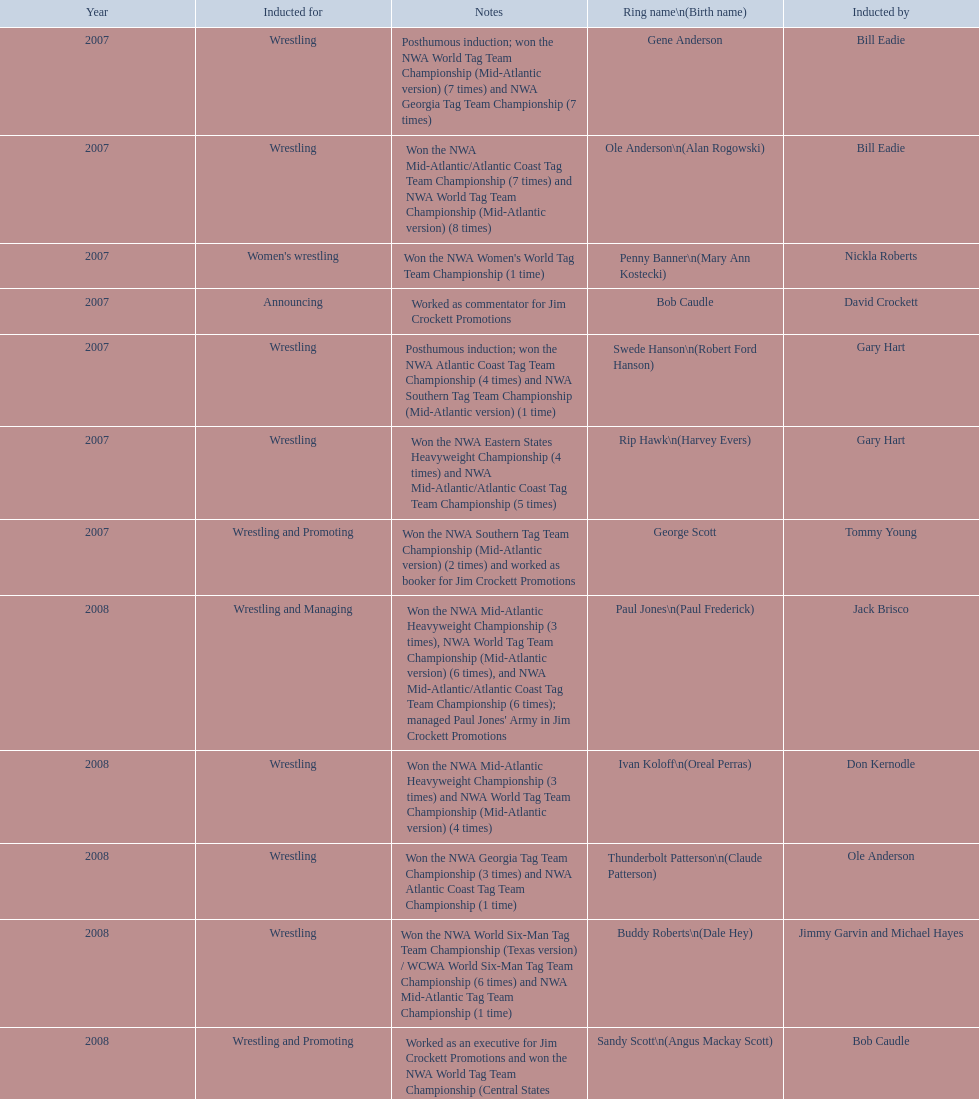Can you give me this table as a dict? {'header': ['Year', 'Inducted for', 'Notes', 'Ring name\\n(Birth name)', 'Inducted by'], 'rows': [['2007', 'Wrestling', 'Posthumous induction; won the NWA World Tag Team Championship (Mid-Atlantic version) (7 times) and NWA Georgia Tag Team Championship (7 times)', 'Gene Anderson', 'Bill Eadie'], ['2007', 'Wrestling', 'Won the NWA Mid-Atlantic/Atlantic Coast Tag Team Championship (7 times) and NWA World Tag Team Championship (Mid-Atlantic version) (8 times)', 'Ole Anderson\\n(Alan Rogowski)', 'Bill Eadie'], ['2007', "Women's wrestling", "Won the NWA Women's World Tag Team Championship (1 time)", 'Penny Banner\\n(Mary Ann Kostecki)', 'Nickla Roberts'], ['2007', 'Announcing', 'Worked as commentator for Jim Crockett Promotions', 'Bob Caudle', 'David Crockett'], ['2007', 'Wrestling', 'Posthumous induction; won the NWA Atlantic Coast Tag Team Championship (4 times) and NWA Southern Tag Team Championship (Mid-Atlantic version) (1 time)', 'Swede Hanson\\n(Robert Ford Hanson)', 'Gary Hart'], ['2007', 'Wrestling', 'Won the NWA Eastern States Heavyweight Championship (4 times) and NWA Mid-Atlantic/Atlantic Coast Tag Team Championship (5 times)', 'Rip Hawk\\n(Harvey Evers)', 'Gary Hart'], ['2007', 'Wrestling and Promoting', 'Won the NWA Southern Tag Team Championship (Mid-Atlantic version) (2 times) and worked as booker for Jim Crockett Promotions', 'George Scott', 'Tommy Young'], ['2008', 'Wrestling and Managing', "Won the NWA Mid-Atlantic Heavyweight Championship (3 times), NWA World Tag Team Championship (Mid-Atlantic version) (6 times), and NWA Mid-Atlantic/Atlantic Coast Tag Team Championship (6 times); managed Paul Jones' Army in Jim Crockett Promotions", 'Paul Jones\\n(Paul Frederick)', 'Jack Brisco'], ['2008', 'Wrestling', 'Won the NWA Mid-Atlantic Heavyweight Championship (3 times) and NWA World Tag Team Championship (Mid-Atlantic version) (4 times)', 'Ivan Koloff\\n(Oreal Perras)', 'Don Kernodle'], ['2008', 'Wrestling', 'Won the NWA Georgia Tag Team Championship (3 times) and NWA Atlantic Coast Tag Team Championship (1 time)', 'Thunderbolt Patterson\\n(Claude Patterson)', 'Ole Anderson'], ['2008', 'Wrestling', 'Won the NWA World Six-Man Tag Team Championship (Texas version) / WCWA World Six-Man Tag Team Championship (6 times) and NWA Mid-Atlantic Tag Team Championship (1 time)', 'Buddy Roberts\\n(Dale Hey)', 'Jimmy Garvin and Michael Hayes'], ['2008', 'Wrestling and Promoting', 'Worked as an executive for Jim Crockett Promotions and won the NWA World Tag Team Championship (Central States version) (1 time) and NWA Southern Tag Team Championship (Mid-Atlantic version) (3 times)', 'Sandy Scott\\n(Angus Mackay Scott)', 'Bob Caudle'], ['2008', 'Wrestling', 'Won the NWA United States Tag Team Championship (Tri-State version) (2 times) and NWA Texas Heavyweight Championship (1 time)', 'Grizzly Smith\\n(Aurelian Smith)', 'Magnum T.A.'], ['2008', 'Wrestling', 'Posthumous induction; won the NWA Atlantic Coast/Mid-Atlantic Tag Team Championship (8 times) and NWA Southern Tag Team Championship (Mid-Atlantic version) (6 times)', 'Johnny Weaver\\n(Kenneth Eugene Weaver)', 'Rip Hawk'], ['2009', 'Wrestling', 'Won the NWA Southern Tag Team Championship (Mid-America version) (2 times) and NWA World Tag Team Championship (Mid-America version) (6 times)', 'Don Fargo\\n(Don Kalt)', 'Jerry Jarrett & Steve Keirn'], ['2009', 'Wrestling', 'Won the NWA World Tag Team Championship (Mid-America version) (10 times) and NWA Southern Tag Team Championship (Mid-America version) (22 times)', 'Jackie Fargo\\n(Henry Faggart)', 'Jerry Jarrett & Steve Keirn'], ['2009', 'Wrestling', 'Posthumous induction; won the NWA Southern Tag Team Championship (Mid-America version) (3 times)', 'Sonny Fargo\\n(Jack Lewis Faggart)', 'Jerry Jarrett & Steve Keirn'], ['2009', 'Managing and Promoting', 'Posthumous induction; worked as a booker in World Class Championship Wrestling and managed several wrestlers in Mid-Atlantic Championship Wrestling', 'Gary Hart\\n(Gary Williams)', 'Sir Oliver Humperdink'], ['2009', 'Wrestling', 'Posthumous induction; won the NWA Mid-Atlantic Heavyweight Championship (6 times) and NWA World Tag Team Championship (Mid-Atlantic version) (4 times)', 'Wahoo McDaniel\\n(Edward McDaniel)', 'Tully Blanchard'], ['2009', 'Wrestling', 'Won the NWA Texas Heavyweight Championship (1 time) and NWA World Tag Team Championship (Mid-Atlantic version) (1 time)', 'Blackjack Mulligan\\n(Robert Windham)', 'Ric Flair'], ['2009', 'Wrestling', 'Won the NWA Atlantic Coast Tag Team Championship (2 times)', 'Nelson Royal', 'Brad Anderson, Tommy Angel & David Isley'], ['2009', 'Announcing', 'Worked as commentator for wrestling events in the Memphis area', 'Lance Russell', 'Dave Brown']]} Who's real name is dale hey, grizzly smith or buddy roberts? Buddy Roberts. 